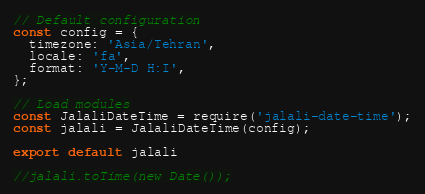<code> <loc_0><loc_0><loc_500><loc_500><_JavaScript_>// Default configuration
const config = {
  timezone: 'Asia/Tehran',
  locale: 'fa',
  format: 'Y-M-D H:I',
};

// Load modules
const JalaliDateTime = require('jalali-date-time');
const jalali = JalaliDateTime(config);

export default jalali

//jalali.toTime(new Date());
</code> 